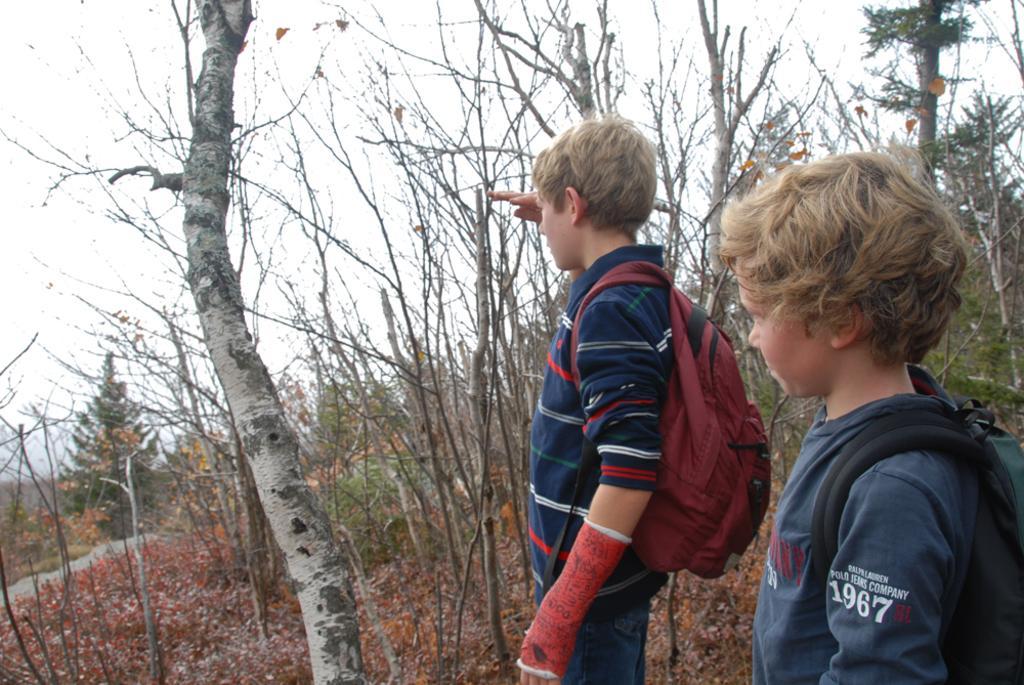Could you give a brief overview of what you see in this image? In this picture, we see two boys are standing and they are wearing the backpacks. At the bottom, we see the dry leaves and twigs. Beside them, we see the trees. There are trees in the background. At the top, we see the sky. 